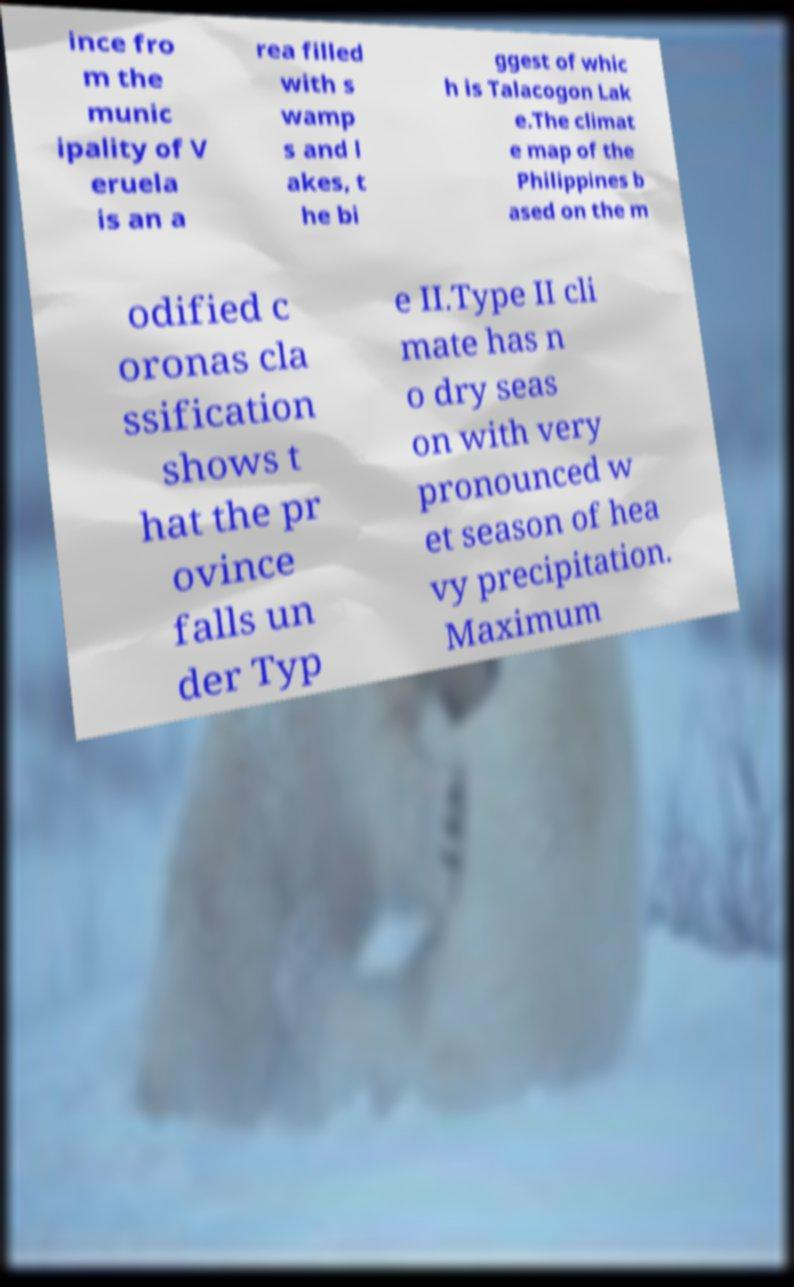Can you accurately transcribe the text from the provided image for me? ince fro m the munic ipality of V eruela is an a rea filled with s wamp s and l akes, t he bi ggest of whic h is Talacogon Lak e.The climat e map of the Philippines b ased on the m odified c oronas cla ssification shows t hat the pr ovince falls un der Typ e II.Type II cli mate has n o dry seas on with very pronounced w et season of hea vy precipitation. Maximum 